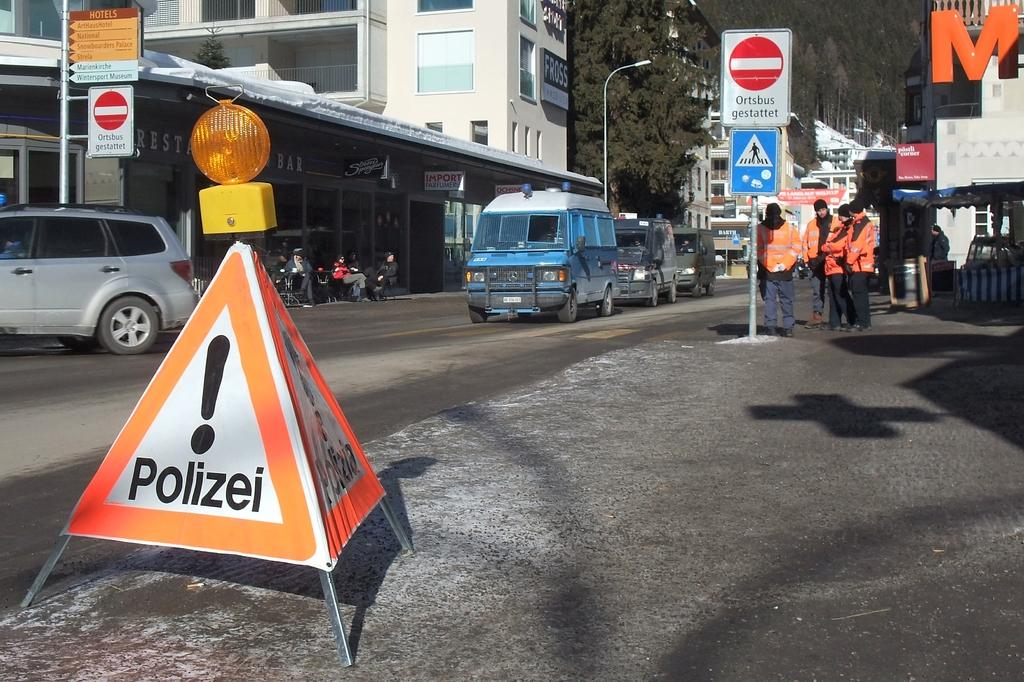<image>
Relay a brief, clear account of the picture shown. A warning sign set up by the Polizei next to a narrow road. 